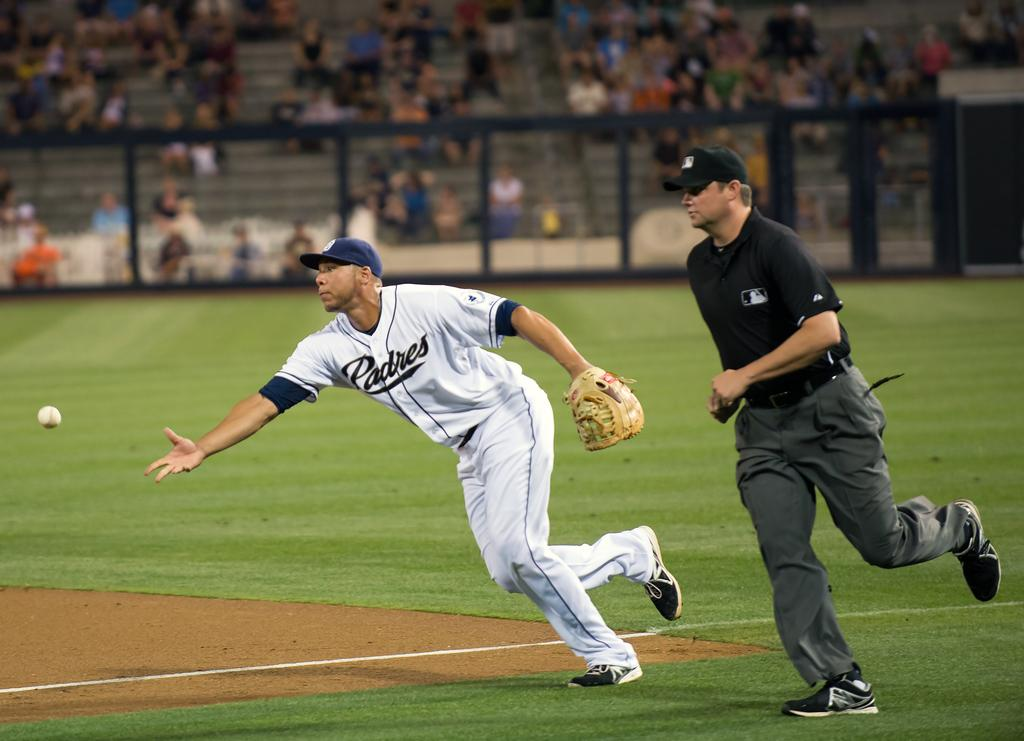<image>
Give a short and clear explanation of the subsequent image. A Padres player tries to catch a baseball with his bare hand. 